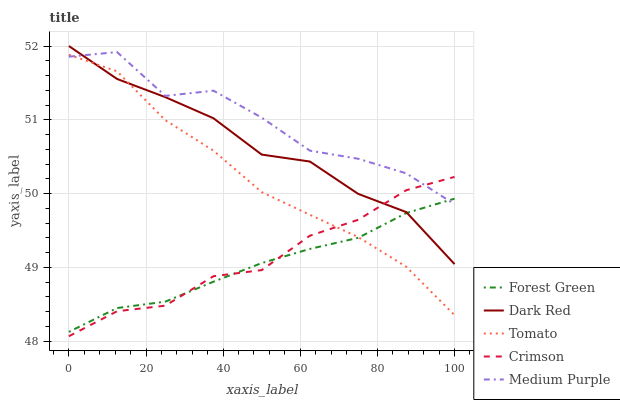Does Forest Green have the minimum area under the curve?
Answer yes or no. Yes. Does Medium Purple have the maximum area under the curve?
Answer yes or no. Yes. Does Dark Red have the minimum area under the curve?
Answer yes or no. No. Does Dark Red have the maximum area under the curve?
Answer yes or no. No. Is Forest Green the smoothest?
Answer yes or no. Yes. Is Medium Purple the roughest?
Answer yes or no. Yes. Is Dark Red the smoothest?
Answer yes or no. No. Is Dark Red the roughest?
Answer yes or no. No. Does Crimson have the lowest value?
Answer yes or no. Yes. Does Dark Red have the lowest value?
Answer yes or no. No. Does Dark Red have the highest value?
Answer yes or no. Yes. Does Forest Green have the highest value?
Answer yes or no. No. Does Dark Red intersect Crimson?
Answer yes or no. Yes. Is Dark Red less than Crimson?
Answer yes or no. No. Is Dark Red greater than Crimson?
Answer yes or no. No. 